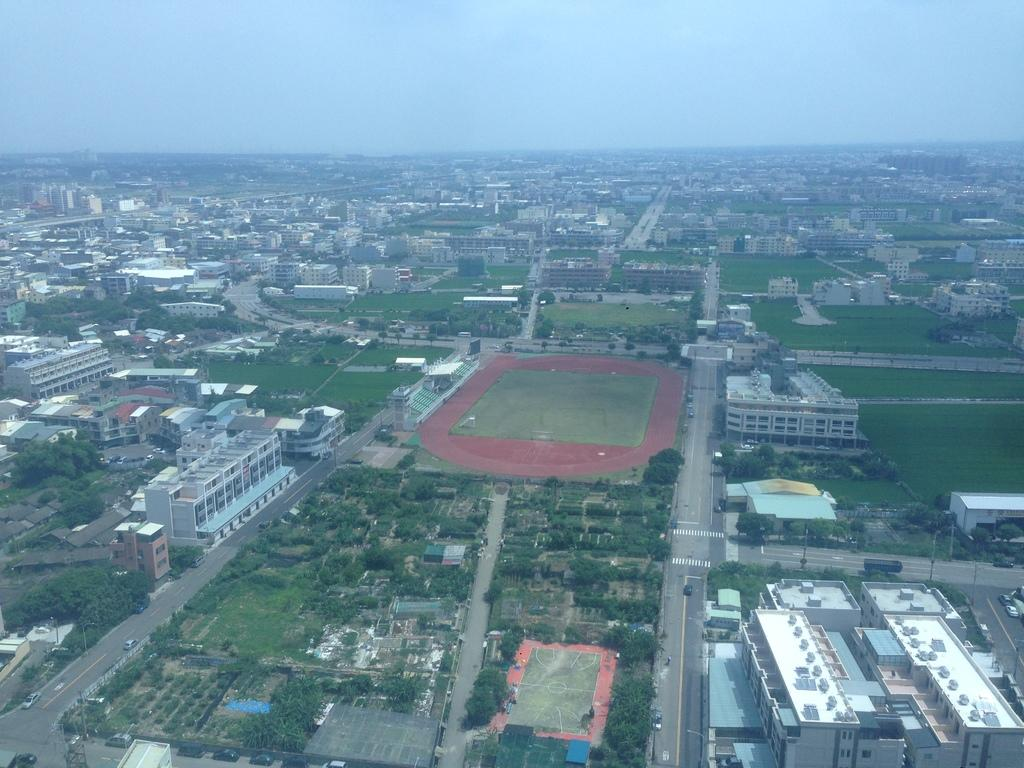What type of location is depicted in the image? The image depicts a city. What structures can be seen in the city? There are buildings in the image. What natural elements are present in the city? There are trees in the image. What man-made objects can be seen in the city? There are poles in the image. What type of transportation is visible in the city? There are vehicles on the road in the image. What part of the natural environment is visible in the image? The sky is visible at the top of the image, and grass is present at the bottom of the image. How many pizzas are being delivered by the ghost in the image? There is no ghost or pizza present in the image. What type of weather is depicted in the image? The image does not depict any specific weather conditions, but the sky is visible at the top of the image. 